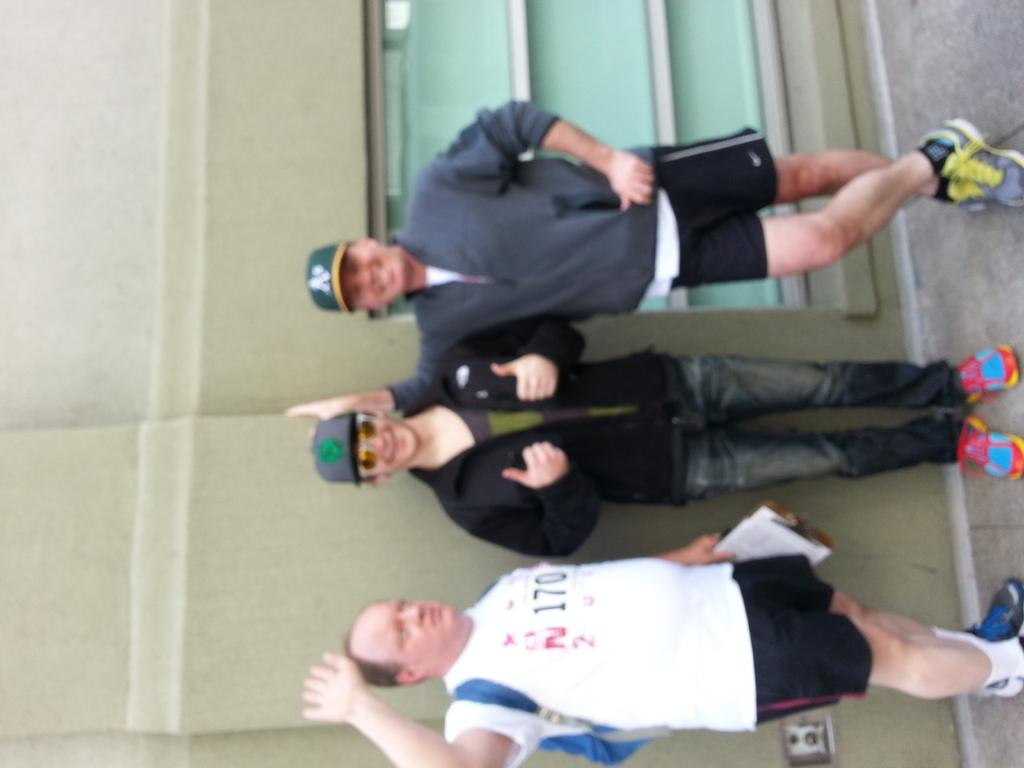How many people are in the image? There are three men in the picture. What is the name of the ice sculpture in the image? There is no ice sculpture present in the image; it features three men. How many hands are visible in the image? The number of hands visible in the image cannot be determined from the provided fact, as it only states that there are three men in the picture. 